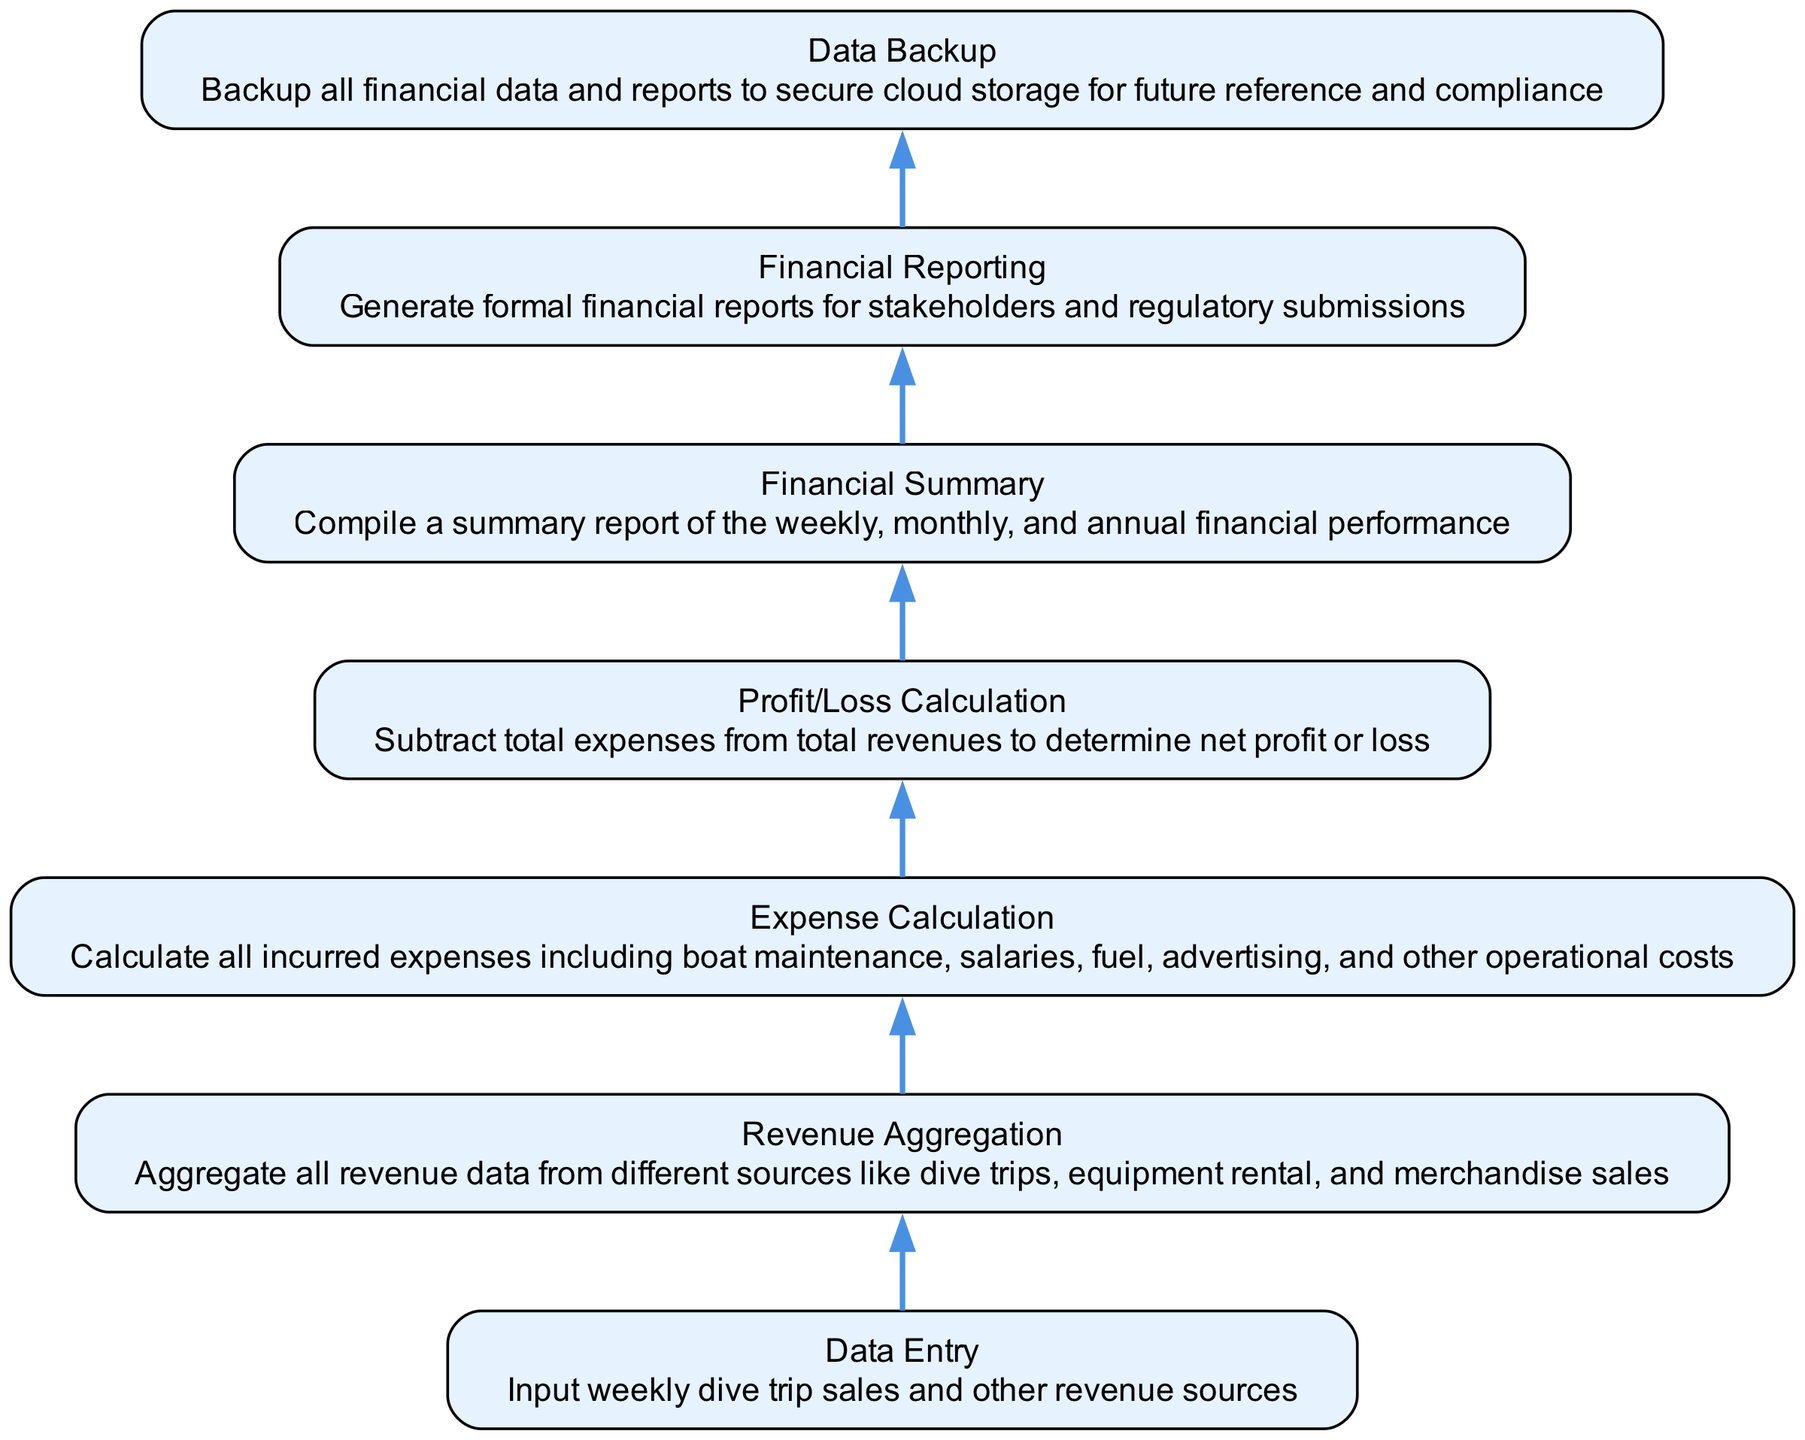What is the first step in the revenue calculation process? The first step is "Data Entry", which involves inputting weekly dive trip sales and other revenue sources. This is the starting point of the flowchart before moving to the next step.
Answer: Data Entry How many steps are involved in the pipeline before financial reporting? The pipeline consists of six steps: Data Entry, Revenue Aggregation, Expense Calculation, Profit/Loss Calculation, Financial Summary, and Financial Reporting. Counting these steps provides the total number.
Answer: Six What is the final outcome of the pipeline? The final step is "Data Backup", which secures all financial data and reports after generating them, ensuring compliance and availability for future reference.
Answer: Data Backup What does "Profit/Loss Calculation" depend on? "Profit/Loss Calculation" requires both total revenue and total expenses to be calculated from previous steps in order to determine the net result. This shows the relationship between revenues and expenses.
Answer: Revenues and Expenses Which step occurs immediately after "Expense Calculation"? The step that comes immediately after "Expense Calculation" is "Profit/Loss Calculation". This direct connection indicates the flow from calculating expenses to determining the profits or losses.
Answer: Profit/Loss Calculation How many different sources are aggregated during "Revenue Aggregation"? "Revenue Aggregation" incorporates various sources such as dive trips, equipment rental, and merchandise sales, although the count is not explicitly mentioned, these three are the specific sources noted.
Answer: Three What is generated for stakeholders at the end of the pipeline? The final product generated for stakeholders at the end of the pipeline is "formal financial reports", which are necessary for transparency and regulatory compliance.
Answer: Financial Reports Which step begins after the financial summary is created? After the "Financial Summary" is compiled, the next step is "Financial Reporting", indicating the progression of finalizing the financial data.
Answer: Financial Reporting What is the purpose of "Data Backup"? The purpose of "Data Backup" is to secure all financial data and reports in cloud storage, ensuring compliance and future accessibility. This is the ultimate goal of maintaining recorded information.
Answer: To secure financial data 